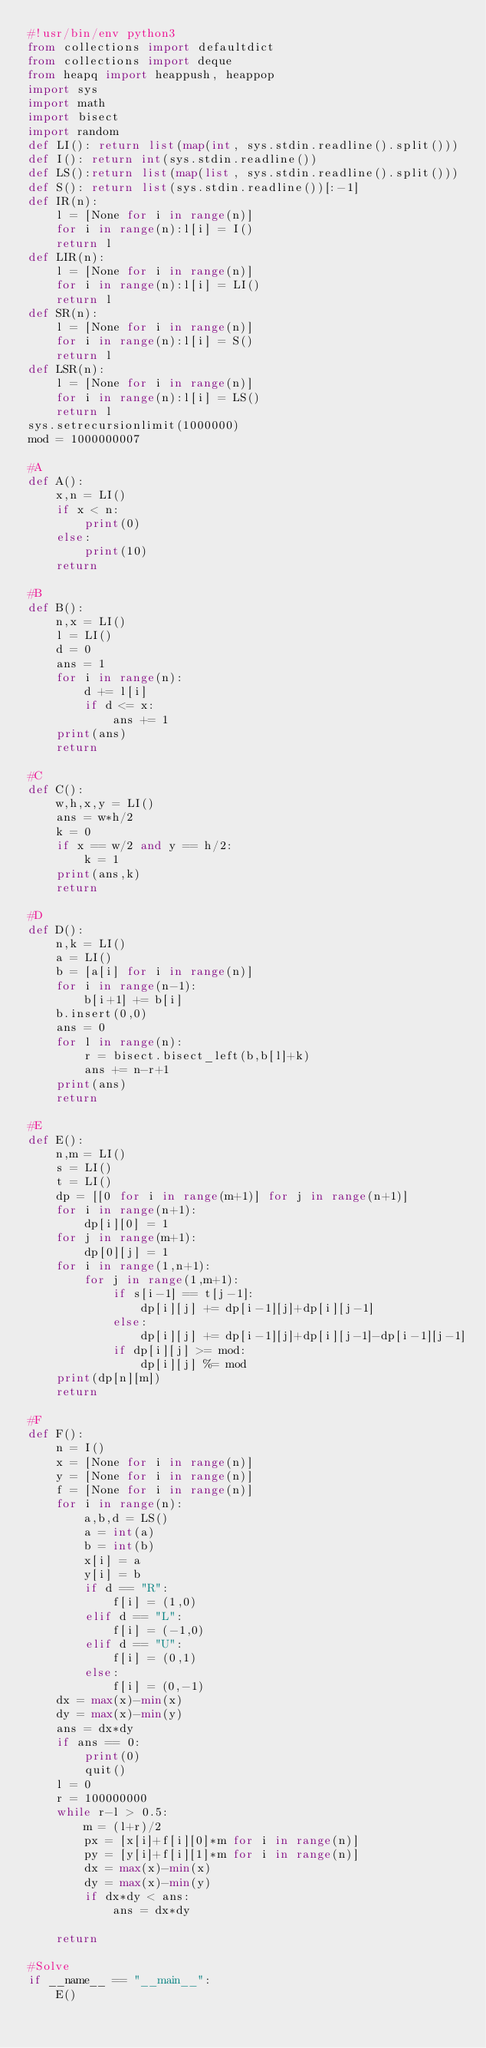<code> <loc_0><loc_0><loc_500><loc_500><_Python_>#!usr/bin/env python3
from collections import defaultdict
from collections import deque
from heapq import heappush, heappop
import sys
import math
import bisect
import random
def LI(): return list(map(int, sys.stdin.readline().split()))
def I(): return int(sys.stdin.readline())
def LS():return list(map(list, sys.stdin.readline().split()))
def S(): return list(sys.stdin.readline())[:-1]
def IR(n):
    l = [None for i in range(n)]
    for i in range(n):l[i] = I()
    return l
def LIR(n):
    l = [None for i in range(n)]
    for i in range(n):l[i] = LI()
    return l
def SR(n):
    l = [None for i in range(n)]
    for i in range(n):l[i] = S()
    return l
def LSR(n):
    l = [None for i in range(n)]
    for i in range(n):l[i] = LS()
    return l
sys.setrecursionlimit(1000000)
mod = 1000000007

#A
def A():
    x,n = LI()
    if x < n:
        print(0)
    else:
        print(10)
    return

#B
def B():
    n,x = LI()
    l = LI()
    d = 0
    ans = 1
    for i in range(n):
        d += l[i]
        if d <= x:
            ans += 1
    print(ans)
    return

#C
def C():
    w,h,x,y = LI()
    ans = w*h/2
    k = 0
    if x == w/2 and y == h/2:
        k = 1
    print(ans,k)
    return

#D
def D():
    n,k = LI()
    a = LI()
    b = [a[i] for i in range(n)]
    for i in range(n-1):
        b[i+1] += b[i]
    b.insert(0,0)
    ans = 0
    for l in range(n):
        r = bisect.bisect_left(b,b[l]+k)
        ans += n-r+1
    print(ans)
    return

#E
def E():
    n,m = LI()
    s = LI()
    t = LI()
    dp = [[0 for i in range(m+1)] for j in range(n+1)]
    for i in range(n+1):
        dp[i][0] = 1
    for j in range(m+1):
        dp[0][j] = 1
    for i in range(1,n+1):
        for j in range(1,m+1):
            if s[i-1] == t[j-1]:
                dp[i][j] += dp[i-1][j]+dp[i][j-1]
            else:
                dp[i][j] += dp[i-1][j]+dp[i][j-1]-dp[i-1][j-1]
            if dp[i][j] >= mod:
                dp[i][j] %= mod
    print(dp[n][m])
    return

#F
def F():
    n = I()
    x = [None for i in range(n)]
    y = [None for i in range(n)]
    f = [None for i in range(n)]
    for i in range(n):
        a,b,d = LS()
        a = int(a)
        b = int(b)
        x[i] = a
        y[i] = b
        if d == "R":
            f[i] = (1,0)
        elif d == "L":
            f[i] = (-1,0)
        elif d == "U":
            f[i] = (0,1)
        else:
            f[i] = (0,-1)
    dx = max(x)-min(x)
    dy = max(x)-min(y)
    ans = dx*dy
    if ans == 0:
        print(0)
        quit()
    l = 0
    r = 100000000
    while r-l > 0.5:
        m = (l+r)/2
        px = [x[i]+f[i][0]*m for i in range(n)]
        py = [y[i]+f[i][1]*m for i in range(n)]
        dx = max(x)-min(x)
        dy = max(x)-min(y)
        if dx*dy < ans:
            ans = dx*dy

    return

#Solve
if __name__ == "__main__":
    E()
</code> 